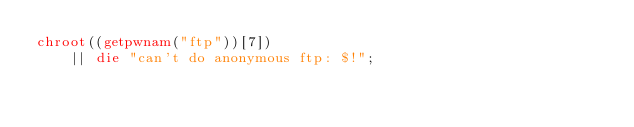<code> <loc_0><loc_0><loc_500><loc_500><_Perl_>chroot((getpwnam("ftp"))[7])
    || die "can't do anonymous ftp: $!";
</code> 